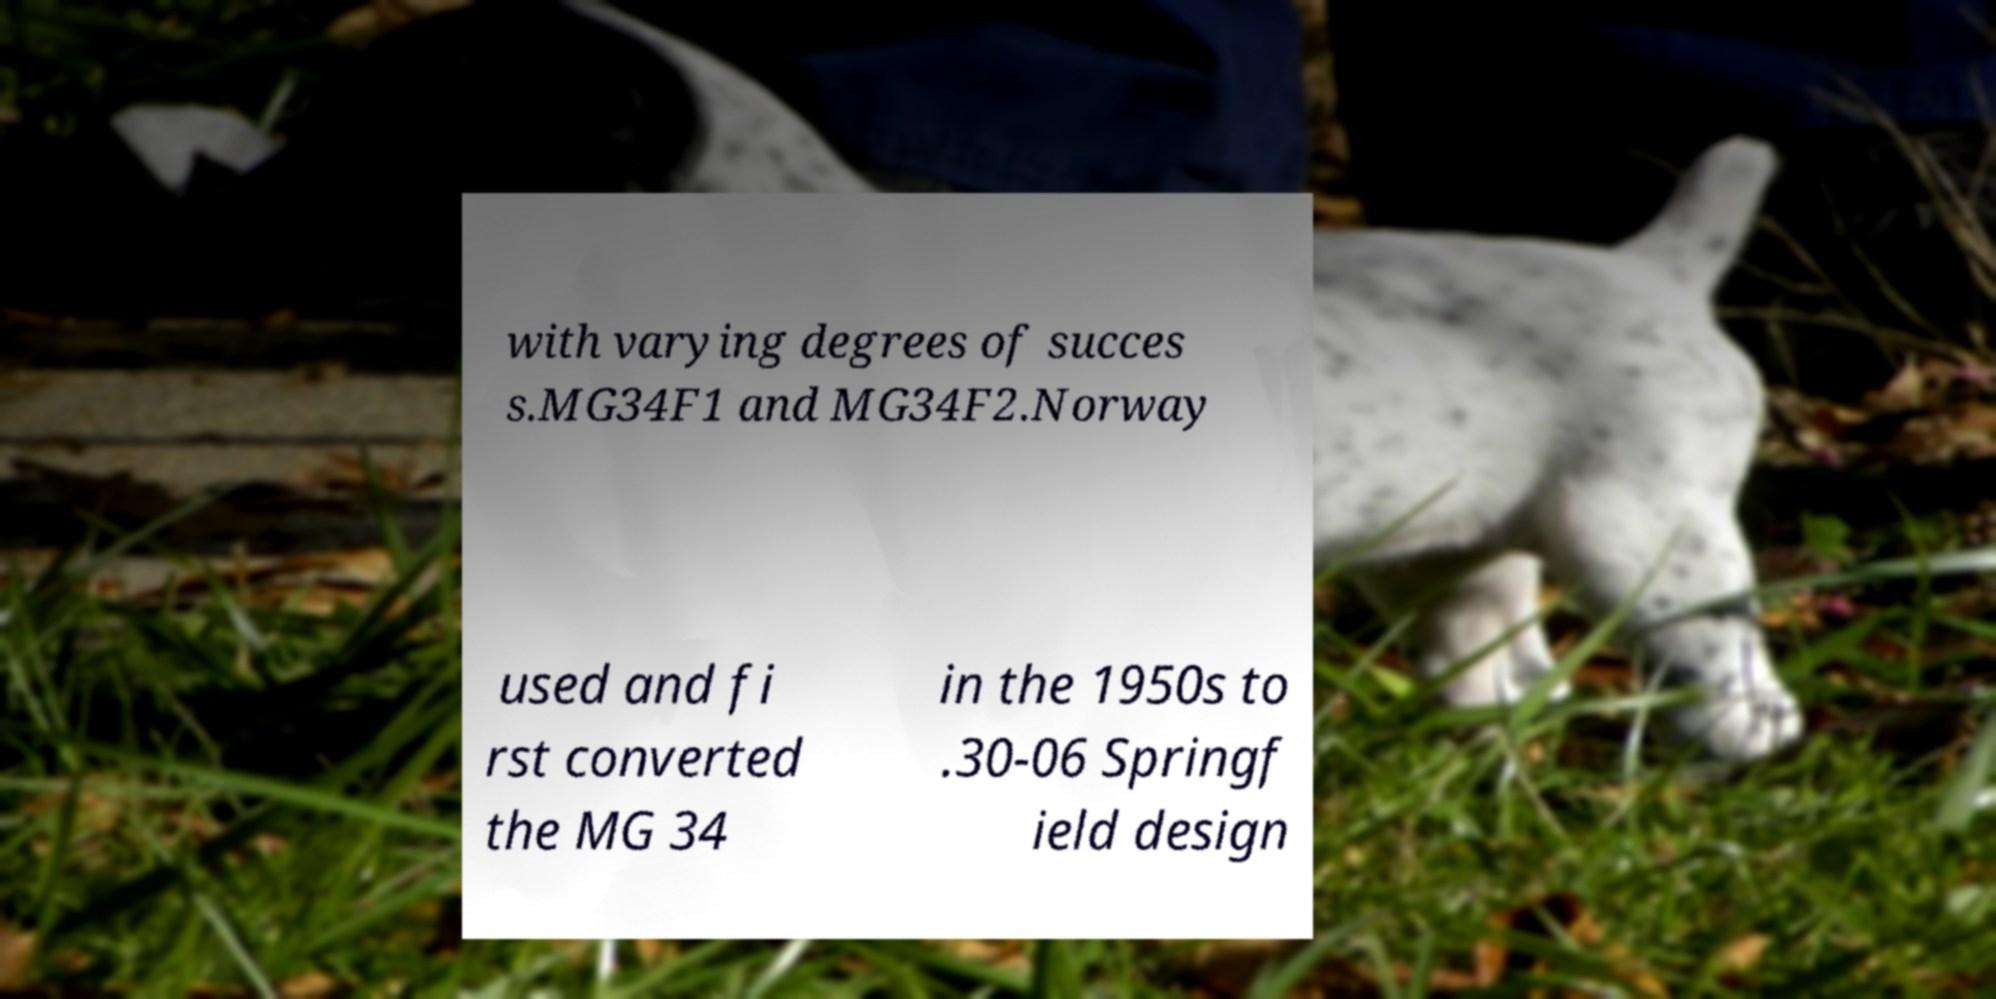What messages or text are displayed in this image? I need them in a readable, typed format. with varying degrees of succes s.MG34F1 and MG34F2.Norway used and fi rst converted the MG 34 in the 1950s to .30-06 Springf ield design 